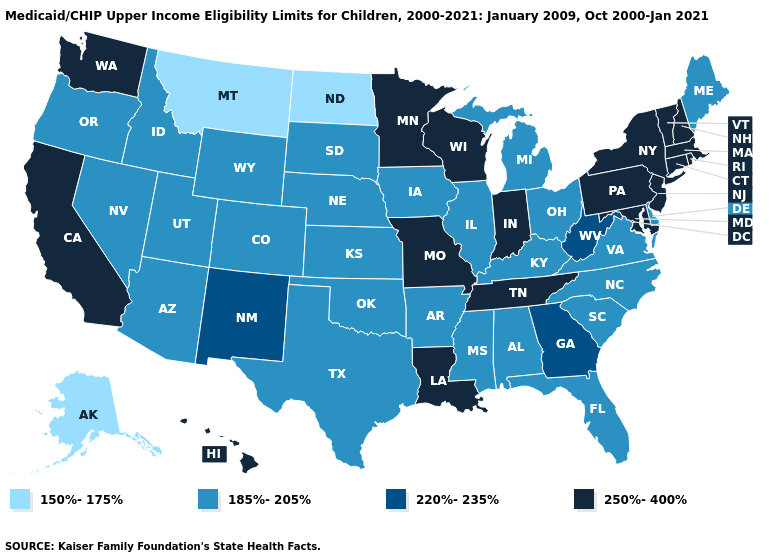How many symbols are there in the legend?
Concise answer only. 4. Which states have the highest value in the USA?
Be succinct. California, Connecticut, Hawaii, Indiana, Louisiana, Maryland, Massachusetts, Minnesota, Missouri, New Hampshire, New Jersey, New York, Pennsylvania, Rhode Island, Tennessee, Vermont, Washington, Wisconsin. Does Wisconsin have the highest value in the MidWest?
Short answer required. Yes. Name the states that have a value in the range 185%-205%?
Keep it brief. Alabama, Arizona, Arkansas, Colorado, Delaware, Florida, Idaho, Illinois, Iowa, Kansas, Kentucky, Maine, Michigan, Mississippi, Nebraska, Nevada, North Carolina, Ohio, Oklahoma, Oregon, South Carolina, South Dakota, Texas, Utah, Virginia, Wyoming. Does Mississippi have the highest value in the South?
Quick response, please. No. Name the states that have a value in the range 220%-235%?
Concise answer only. Georgia, New Mexico, West Virginia. Name the states that have a value in the range 250%-400%?
Quick response, please. California, Connecticut, Hawaii, Indiana, Louisiana, Maryland, Massachusetts, Minnesota, Missouri, New Hampshire, New Jersey, New York, Pennsylvania, Rhode Island, Tennessee, Vermont, Washington, Wisconsin. Which states hav the highest value in the South?
Answer briefly. Louisiana, Maryland, Tennessee. Does Pennsylvania have the highest value in the Northeast?
Concise answer only. Yes. Does Wyoming have a higher value than Montana?
Quick response, please. Yes. Which states hav the highest value in the South?
Give a very brief answer. Louisiana, Maryland, Tennessee. Does Colorado have the highest value in the USA?
Be succinct. No. Which states hav the highest value in the MidWest?
Concise answer only. Indiana, Minnesota, Missouri, Wisconsin. Which states have the lowest value in the USA?
Short answer required. Alaska, Montana, North Dakota. Which states have the highest value in the USA?
Quick response, please. California, Connecticut, Hawaii, Indiana, Louisiana, Maryland, Massachusetts, Minnesota, Missouri, New Hampshire, New Jersey, New York, Pennsylvania, Rhode Island, Tennessee, Vermont, Washington, Wisconsin. 